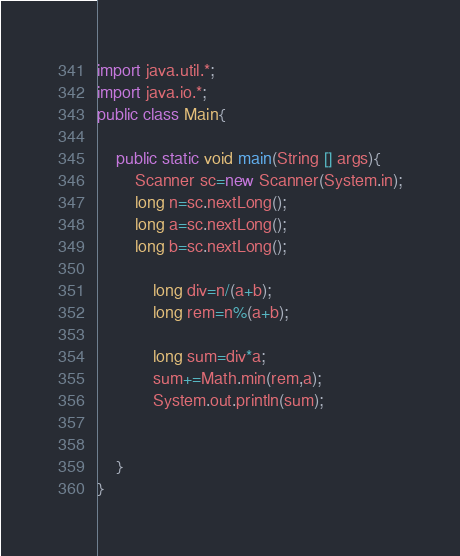<code> <loc_0><loc_0><loc_500><loc_500><_Java_>import java.util.*;
import java.io.*;
public class Main{
  
    public static void main(String [] args){
        Scanner sc=new Scanner(System.in);
        long n=sc.nextLong();
        long a=sc.nextLong();
        long b=sc.nextLong();
    
            long div=n/(a+b);
            long rem=n%(a+b);
            
            long sum=div*a;
            sum+=Math.min(rem,a);
            System.out.println(sum);


    }
}</code> 